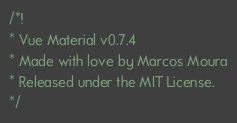<code> <loc_0><loc_0><loc_500><loc_500><_JavaScript_>/*!
* Vue Material v0.7.4
* Made with love by Marcos Moura
* Released under the MIT License.
*/   </code> 